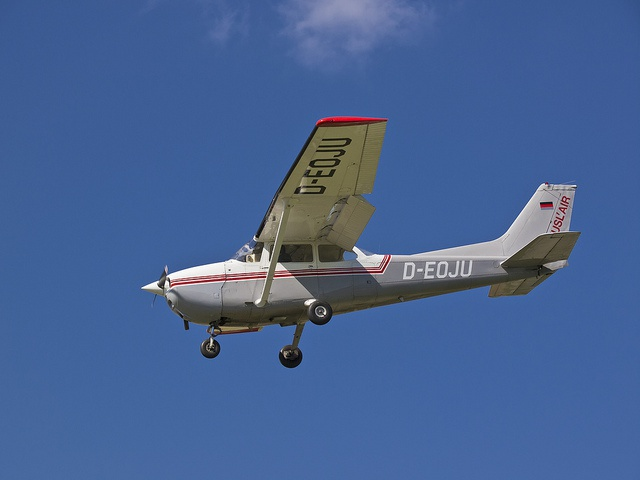Describe the objects in this image and their specific colors. I can see a airplane in blue, gray, black, and darkgray tones in this image. 